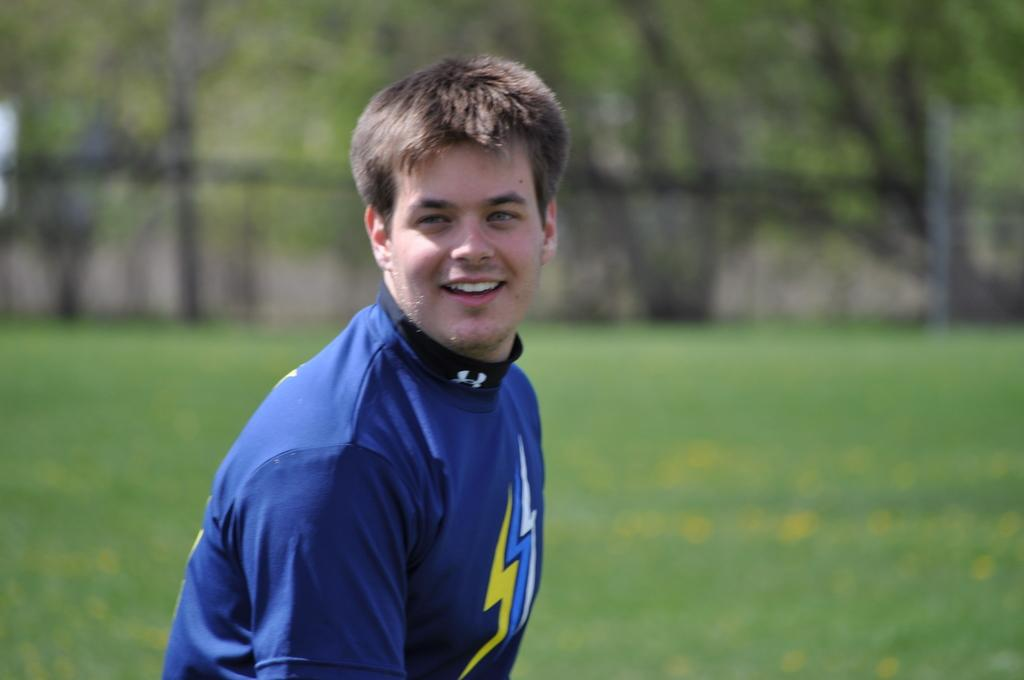Who or what is present in the image? There is a person in the image. What is the person doing or expressing? The person is smiling. What can be seen in the background of the image? There is greenery in the background of the image. What type of crime is being committed in the image? There is no crime being committed in the image; it features a person smiling with greenery in the background. What is the person using to carry a heavy load in the image? There is no yoke or heavy load present in the image; it only shows a person smiling with greenery in the background. 